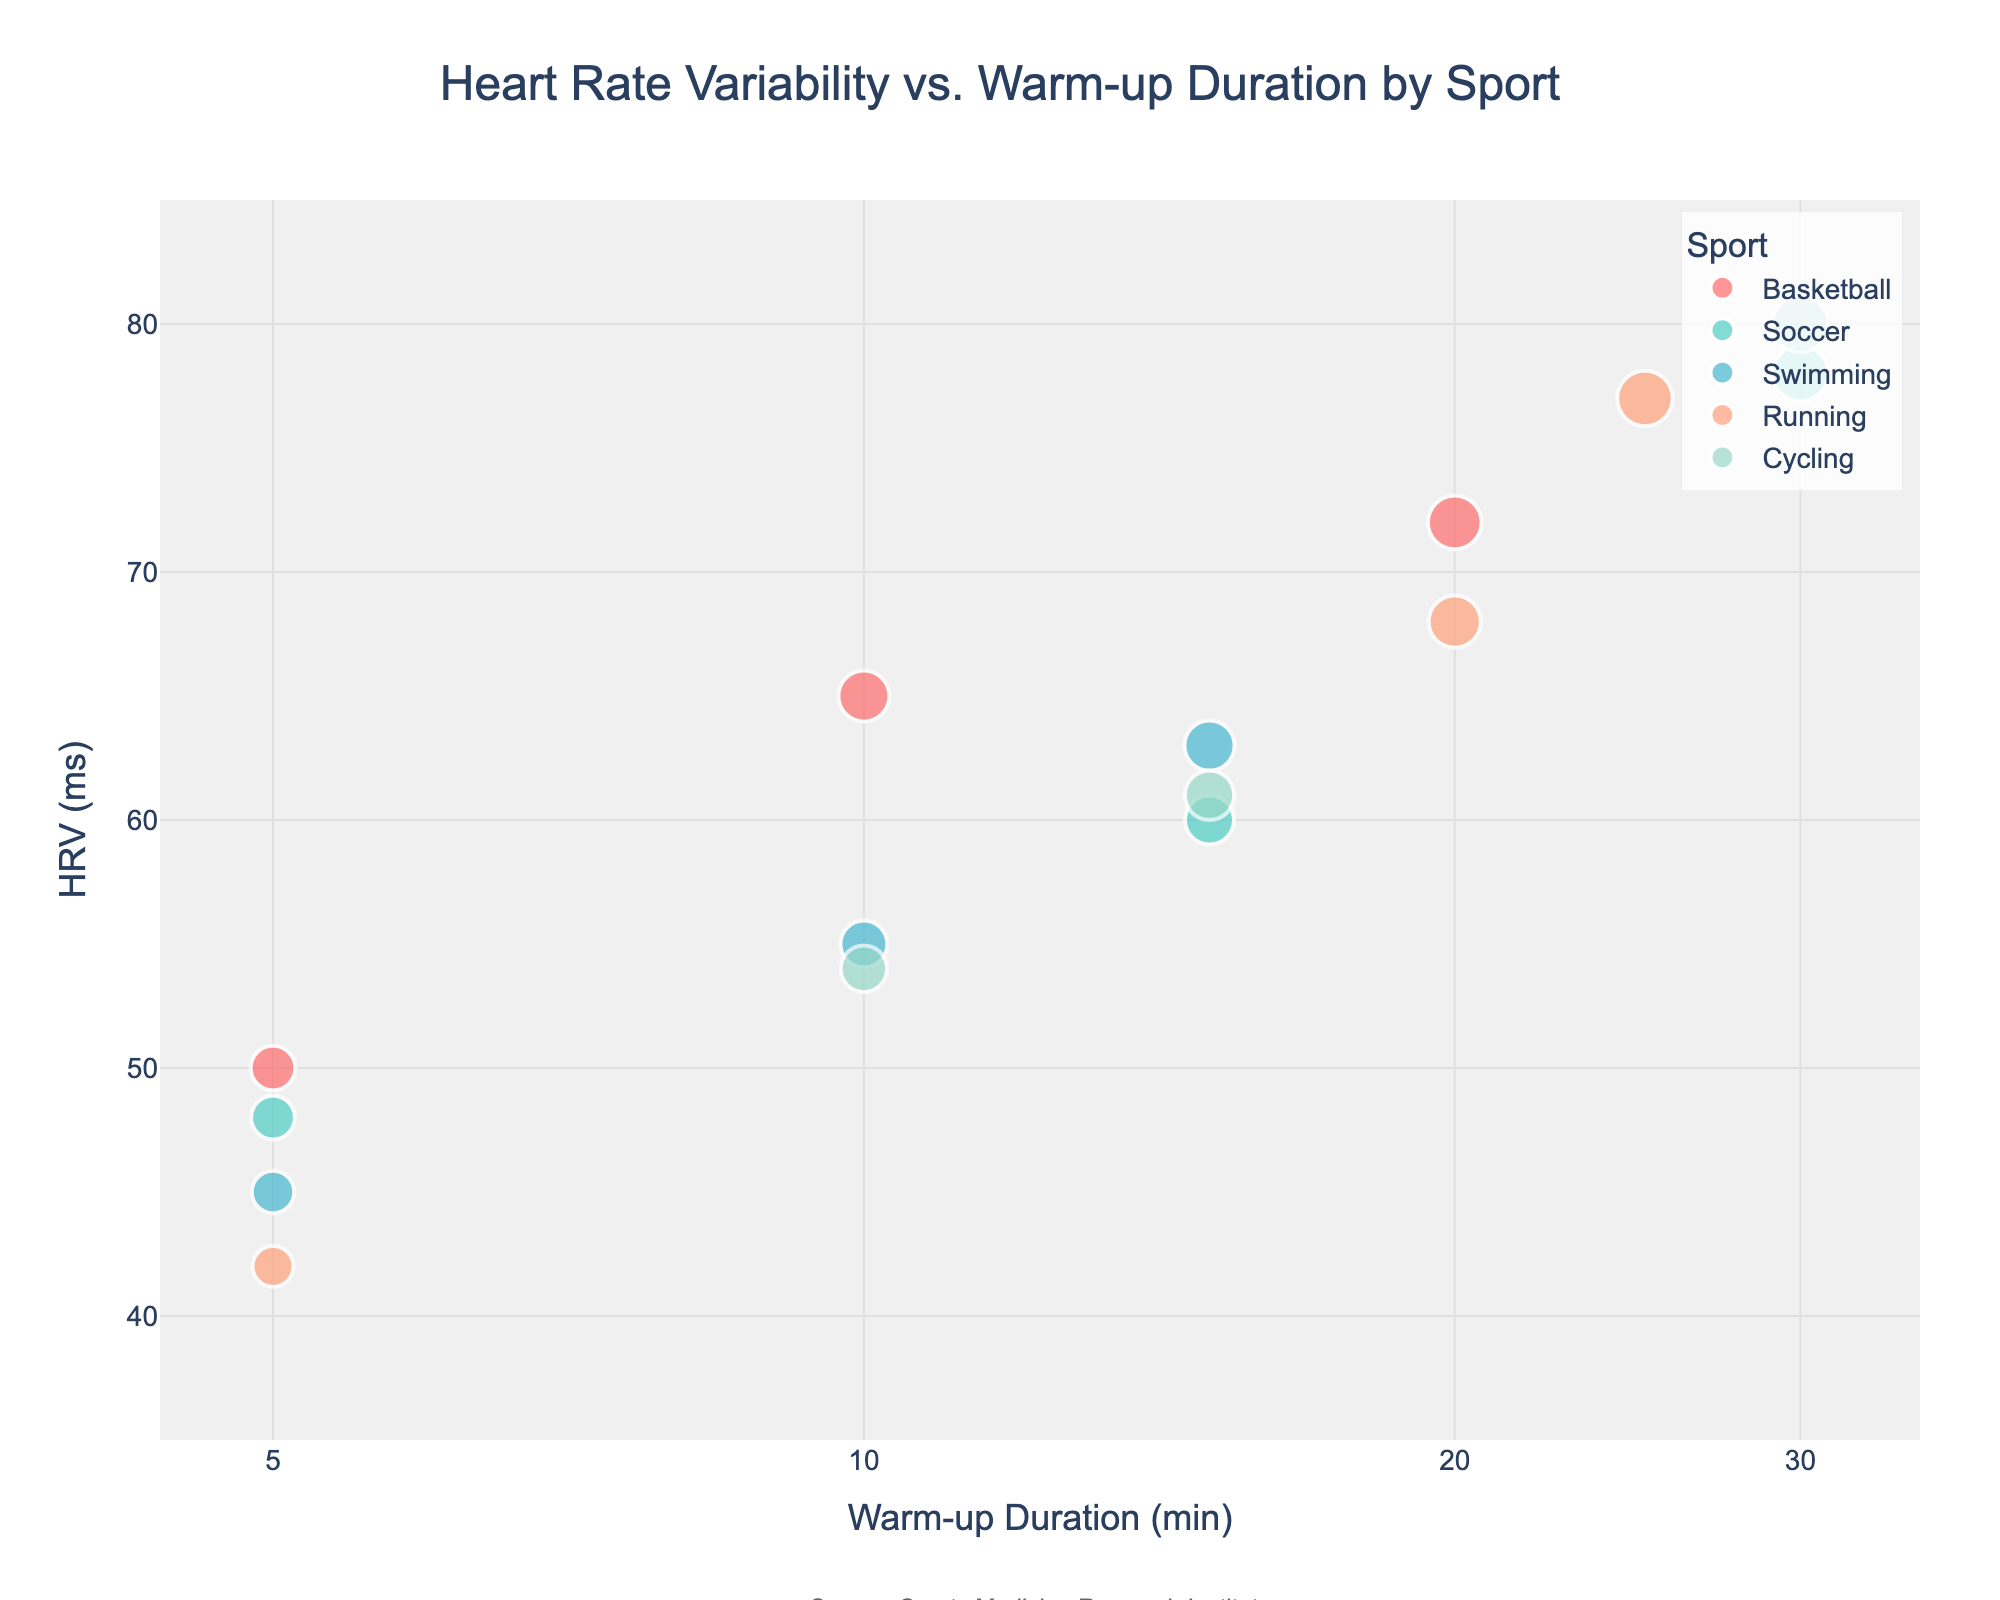What's the title of the plot? The title is located at the top center of the plot and is written in a large font. It summarizes the purpose of the figure.
Answer: Heart Rate Variability vs. Warm-up Duration by Sport How many sports are represented in the plot? Each sport has unique colors and labels, which can be easily counted in the legend on the top right of the plot.
Answer: 5 Which sport has the highest Heart Rate Variability (HRV)? By looking for the highest value on the y-axis and noting the associated data point's color and corresponding label in the legend, we can determine the sport. The highest HRV is 80 ms, which falls under Cycling.
Answer: Cycling What is the range of warm-up durations shown on the x-axis? The x-axis represents the warm-up duration in a log scale, and the tick marks show the start and end of this range. The range includes the smallest and largest values provided.
Answer: 5 to 30 minutes What is the HRV for soccer at 5 minutes of warm-up? By identifying the data point for soccer with a warm-up duration of 5 minutes on the x-axis, its corresponding y-axis value gives the HRV.
Answer: 48 ms Calculate the average HRV for running. Identify all HRV values for running from the plot (42, 68, 77), sum them up and then divide by the number of values. (42 + 68 + 77) / 3 = 187 / 3
Answer: 62.3 ms Compare the average HRV between basketball and swimming. Which sport has a higher average HRV? Calculate the average for both sports first. Basketball: (50 + 65 + 72) / 3 = 62.33, Swimming: (45 + 55 + 63) / 3 = 54.33. Basketball has a higher average HRV.
Answer: Basketball Which sport shows the greatest variation in HRV based on the plotted data points? Look at the distribution and range of HRV values for each sport by observing the vertical spread of their data points. Soccer ranges from 48 to 78 ms, the widest range.
Answer: Soccer Which duration of warm-up is associated with the lowest HRV value in the entire plot? Identify the point with the smallest y-axis value, which represents the lowest HRV, then check the corresponding x-axis value for the warm-up duration.
Answer: 5 minutes What trend or pattern do you observe about HRV as the warm-up duration increases? Examine the overall distribution of data points as warm-up duration increases on the x-axis and the general trend in HRV on the y-axis. There is a tendency for HRV to increase with longer warm-up durations.
Answer: HRV generally increases with longer warm-ups 